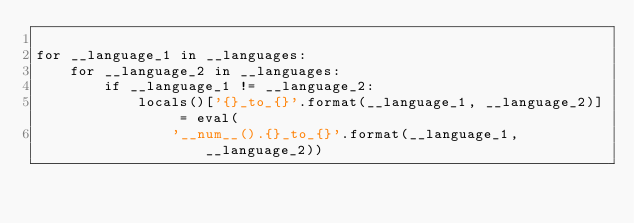<code> <loc_0><loc_0><loc_500><loc_500><_Python_>
for __language_1 in __languages:
    for __language_2 in __languages:
        if __language_1 != __language_2:
            locals()['{}_to_{}'.format(__language_1, __language_2)] = eval(
                '__num__().{}_to_{}'.format(__language_1, __language_2))
</code> 